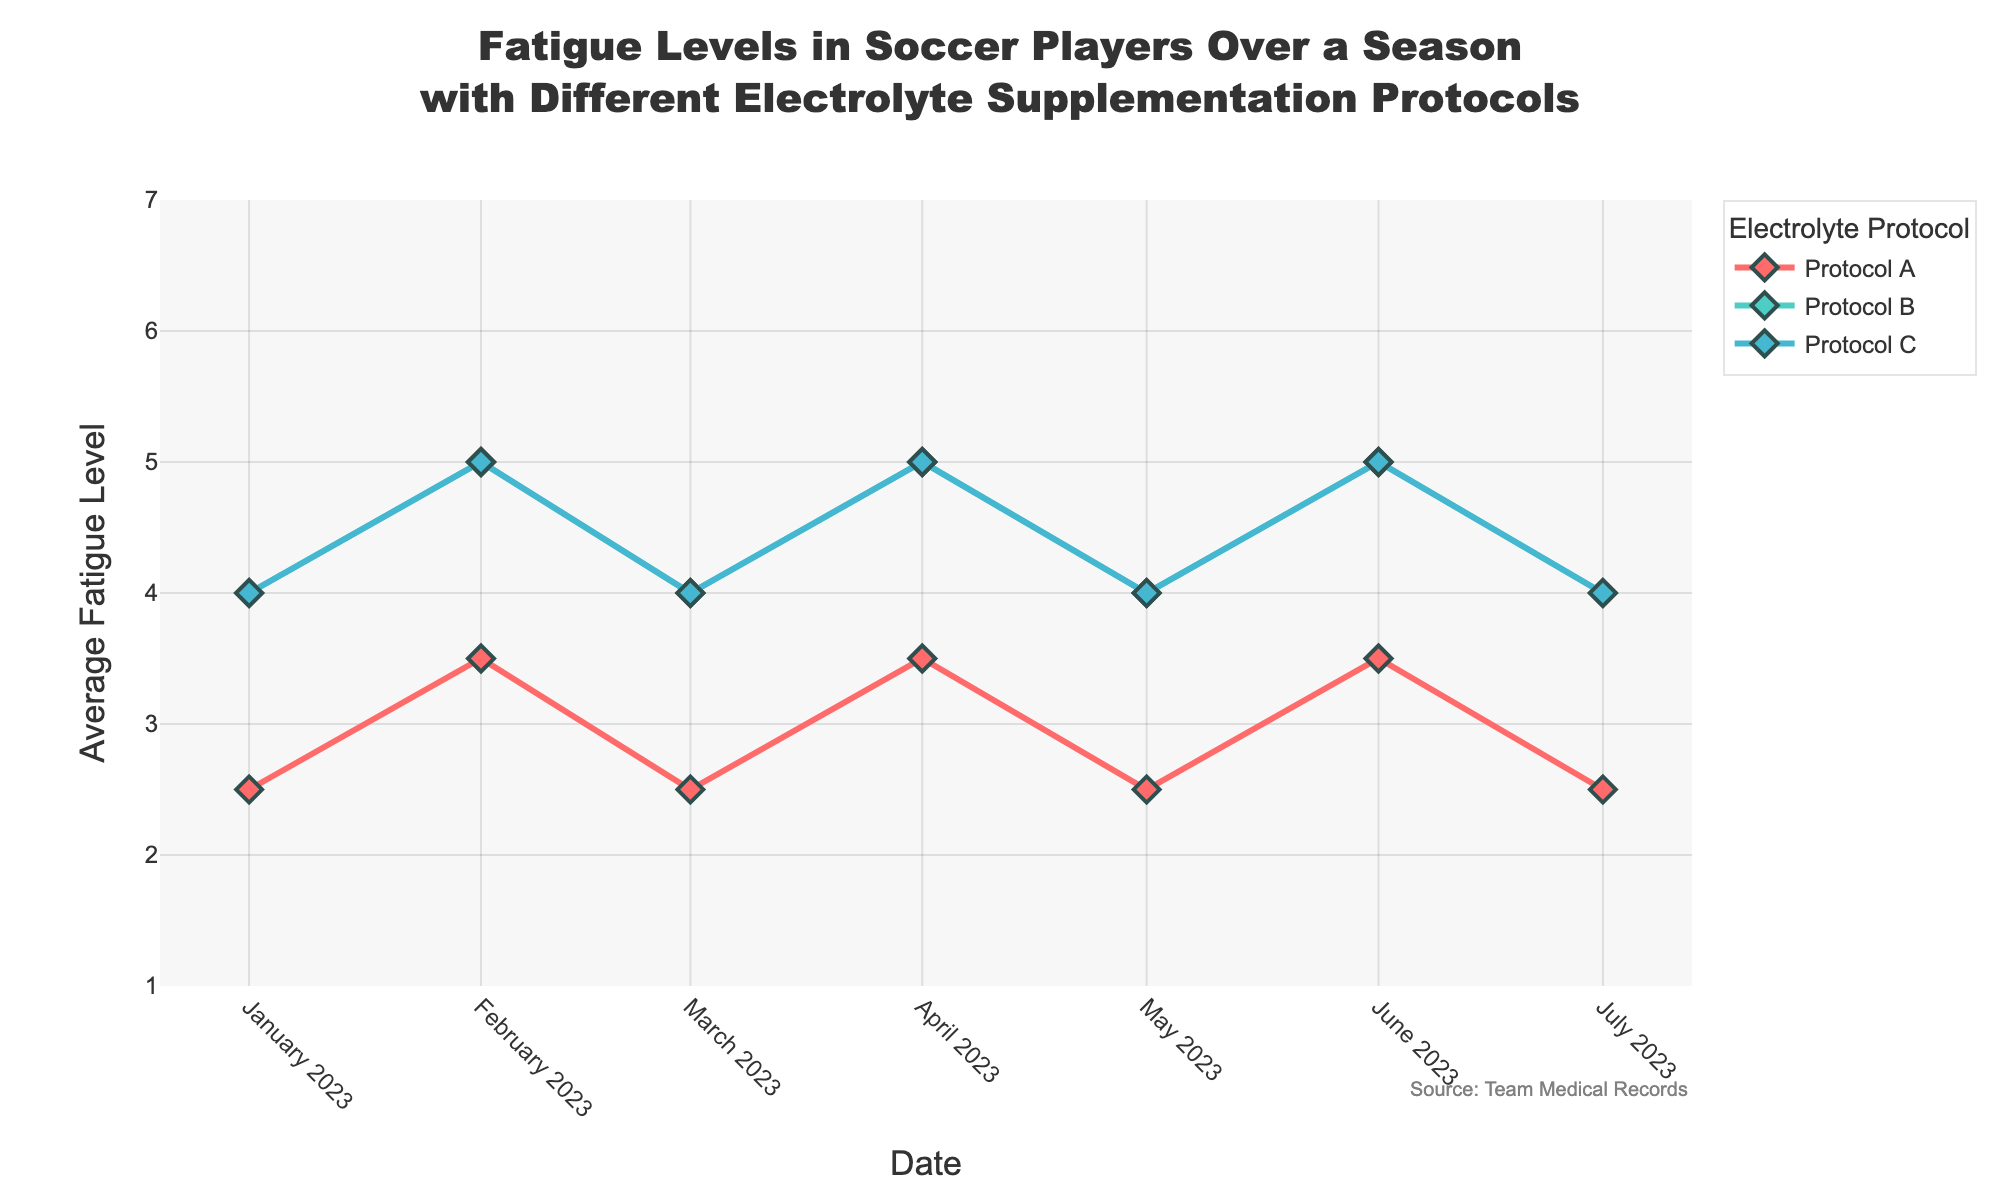What is the title of the plot? The title of the plot is placed at the top center of the figure. It reads, "Fatigue Levels in Soccer Players Over a Season with Different Electrolyte Supplementation Protocols".
Answer: Fatigue Levels in Soccer Players Over a Season with Different Electrolyte Supplementation Protocols What is the range of the y-axis? The y-axis range is displayed on the left-hand side of the plot. The lowest tick is at 1 and the highest tick is at 7.
Answer: 1 to 7 How many electrolyte protocols are represented in the plot? The legend on the right-hand side of the plot lists each electrolyte protocol. There are three protocols represented: A, B, and C.
Answer: 3 For which protocol does the average fatigue level show the most fluctuations over the season? By observing the lines representing different protocols, Protocol B appears to show the most fluctuations as its line goes up and down more frequently compared to Protocols A and C.
Answer: Protocol B On which dates do Protocol A and Protocol B have equal average fatigue levels? By tracing the lines for Protocol A and Protocol B on the timeline, they can be seen to meet on January 1, March 1, May 1, and July 1.
Answer: January 1, March 1, May 1, July 1 Which protocol demonstrates the highest average fatigue level at any point in time? By inspecting the peaks of each line, Protocol B demonstrates the highest average fatigue level, which is 6, on several dates including February 1, April 1, June 1.
Answer: Protocol B Calculate the average fatigue level for Protocol C from January 2023 to July 2023. The average fatigue level for Protocol C can be calculated by adding the monthly average fatigue levels and dividing by the number of months. That is, (4 + 5 + 4 + 5 + 4 + 5 + 4) / 7 = 31 / 7 ≈ 4.43.
Answer: 4.43 How does the trend for Protocol A differ from that of Protocol C over the season? By comparing Protocol A and C lines, Protocol A shows a 2-month cycle of lower and then higher fatigue levels, whereas Protocol C maintains a relatively stable, slightly undulating pattern.
Answer: Protocol A is more cyclic, Protocol C is more stable Which electrolyte protocol has the lowest average fatigue level in March 2023? In March 2023, the line for Protocol A is the lowest compared to Protocol B and C.
Answer: Protocol A On which date do all protocols show the same average fatigue level? By examining where all the lines intersect simultaneously, this occurs on January 1 and July 1.
Answer: January 1 and July 1 